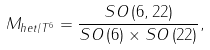Convert formula to latex. <formula><loc_0><loc_0><loc_500><loc_500>M _ { h e t / T ^ { 6 } } = \frac { S O \left ( 6 , 2 2 \right ) } { S O \left ( 6 \right ) \times S O \left ( 2 2 \right ) } ,</formula> 